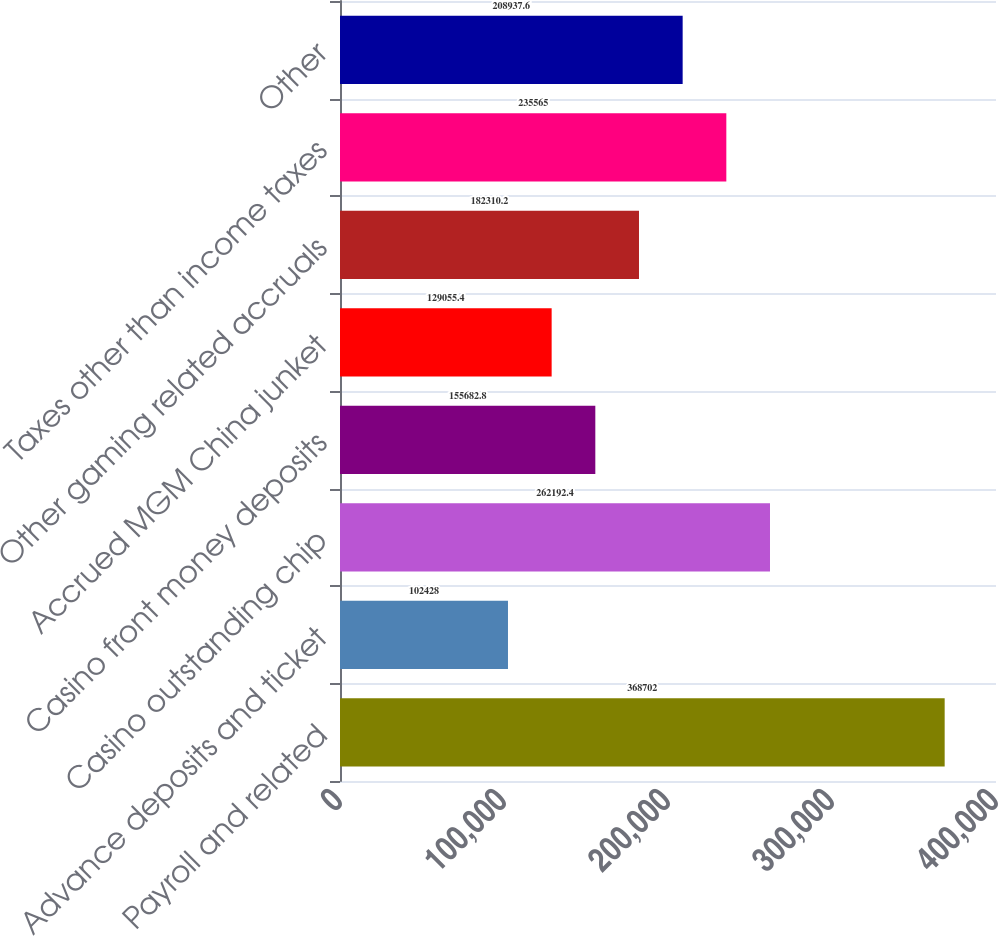Convert chart. <chart><loc_0><loc_0><loc_500><loc_500><bar_chart><fcel>Payroll and related<fcel>Advance deposits and ticket<fcel>Casino outstanding chip<fcel>Casino front money deposits<fcel>Accrued MGM China junket<fcel>Other gaming related accruals<fcel>Taxes other than income taxes<fcel>Other<nl><fcel>368702<fcel>102428<fcel>262192<fcel>155683<fcel>129055<fcel>182310<fcel>235565<fcel>208938<nl></chart> 